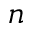<formula> <loc_0><loc_0><loc_500><loc_500>n</formula> 